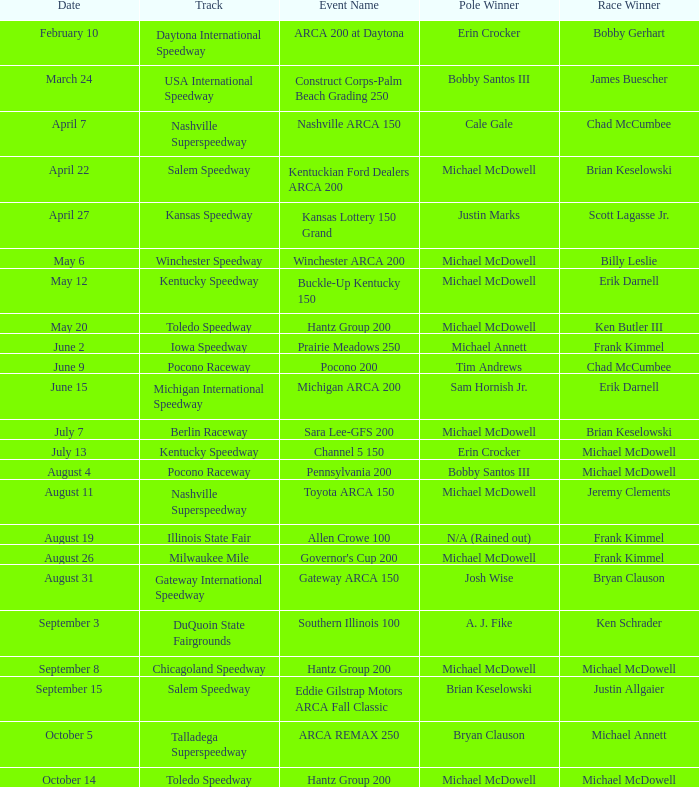Tell me the track for scott lagasse jr. Kansas Speedway. 